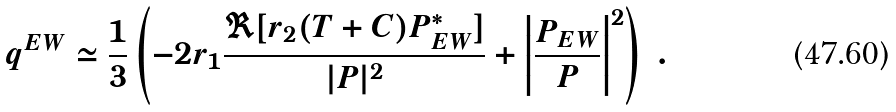<formula> <loc_0><loc_0><loc_500><loc_500>q ^ { E W } \simeq \frac { 1 } { 3 } \left ( - 2 r _ { 1 } \frac { \Re [ r _ { 2 } ( T + C ) P _ { E W } ^ { \ast } ] } { | P | ^ { 2 } } + \left | \frac { P _ { E W } } { P } \right | ^ { 2 } \right ) \ .</formula> 